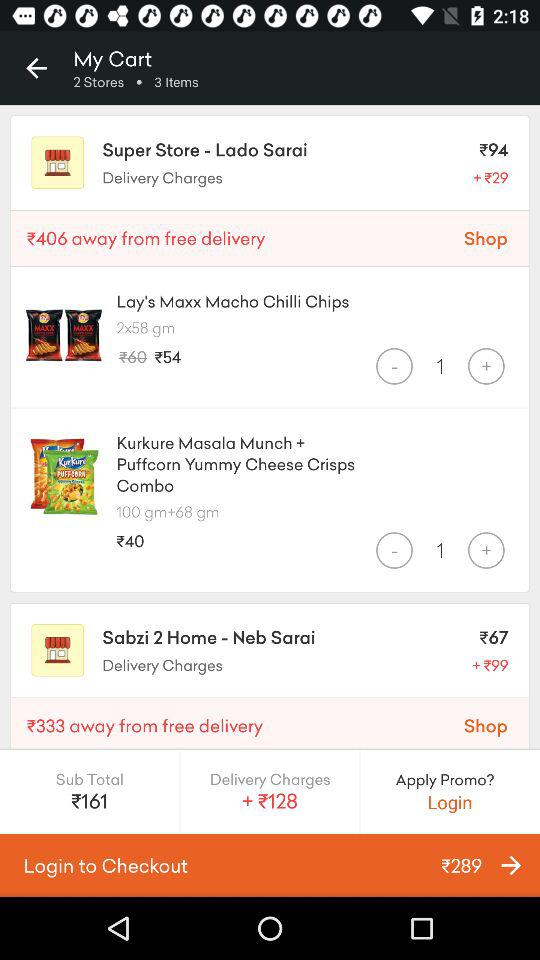What is the selected quantity of Lay's Maxx Macho Chilli Chips? The selected quantity of Lay's Maxx Macho Chilli Chips is 1. 